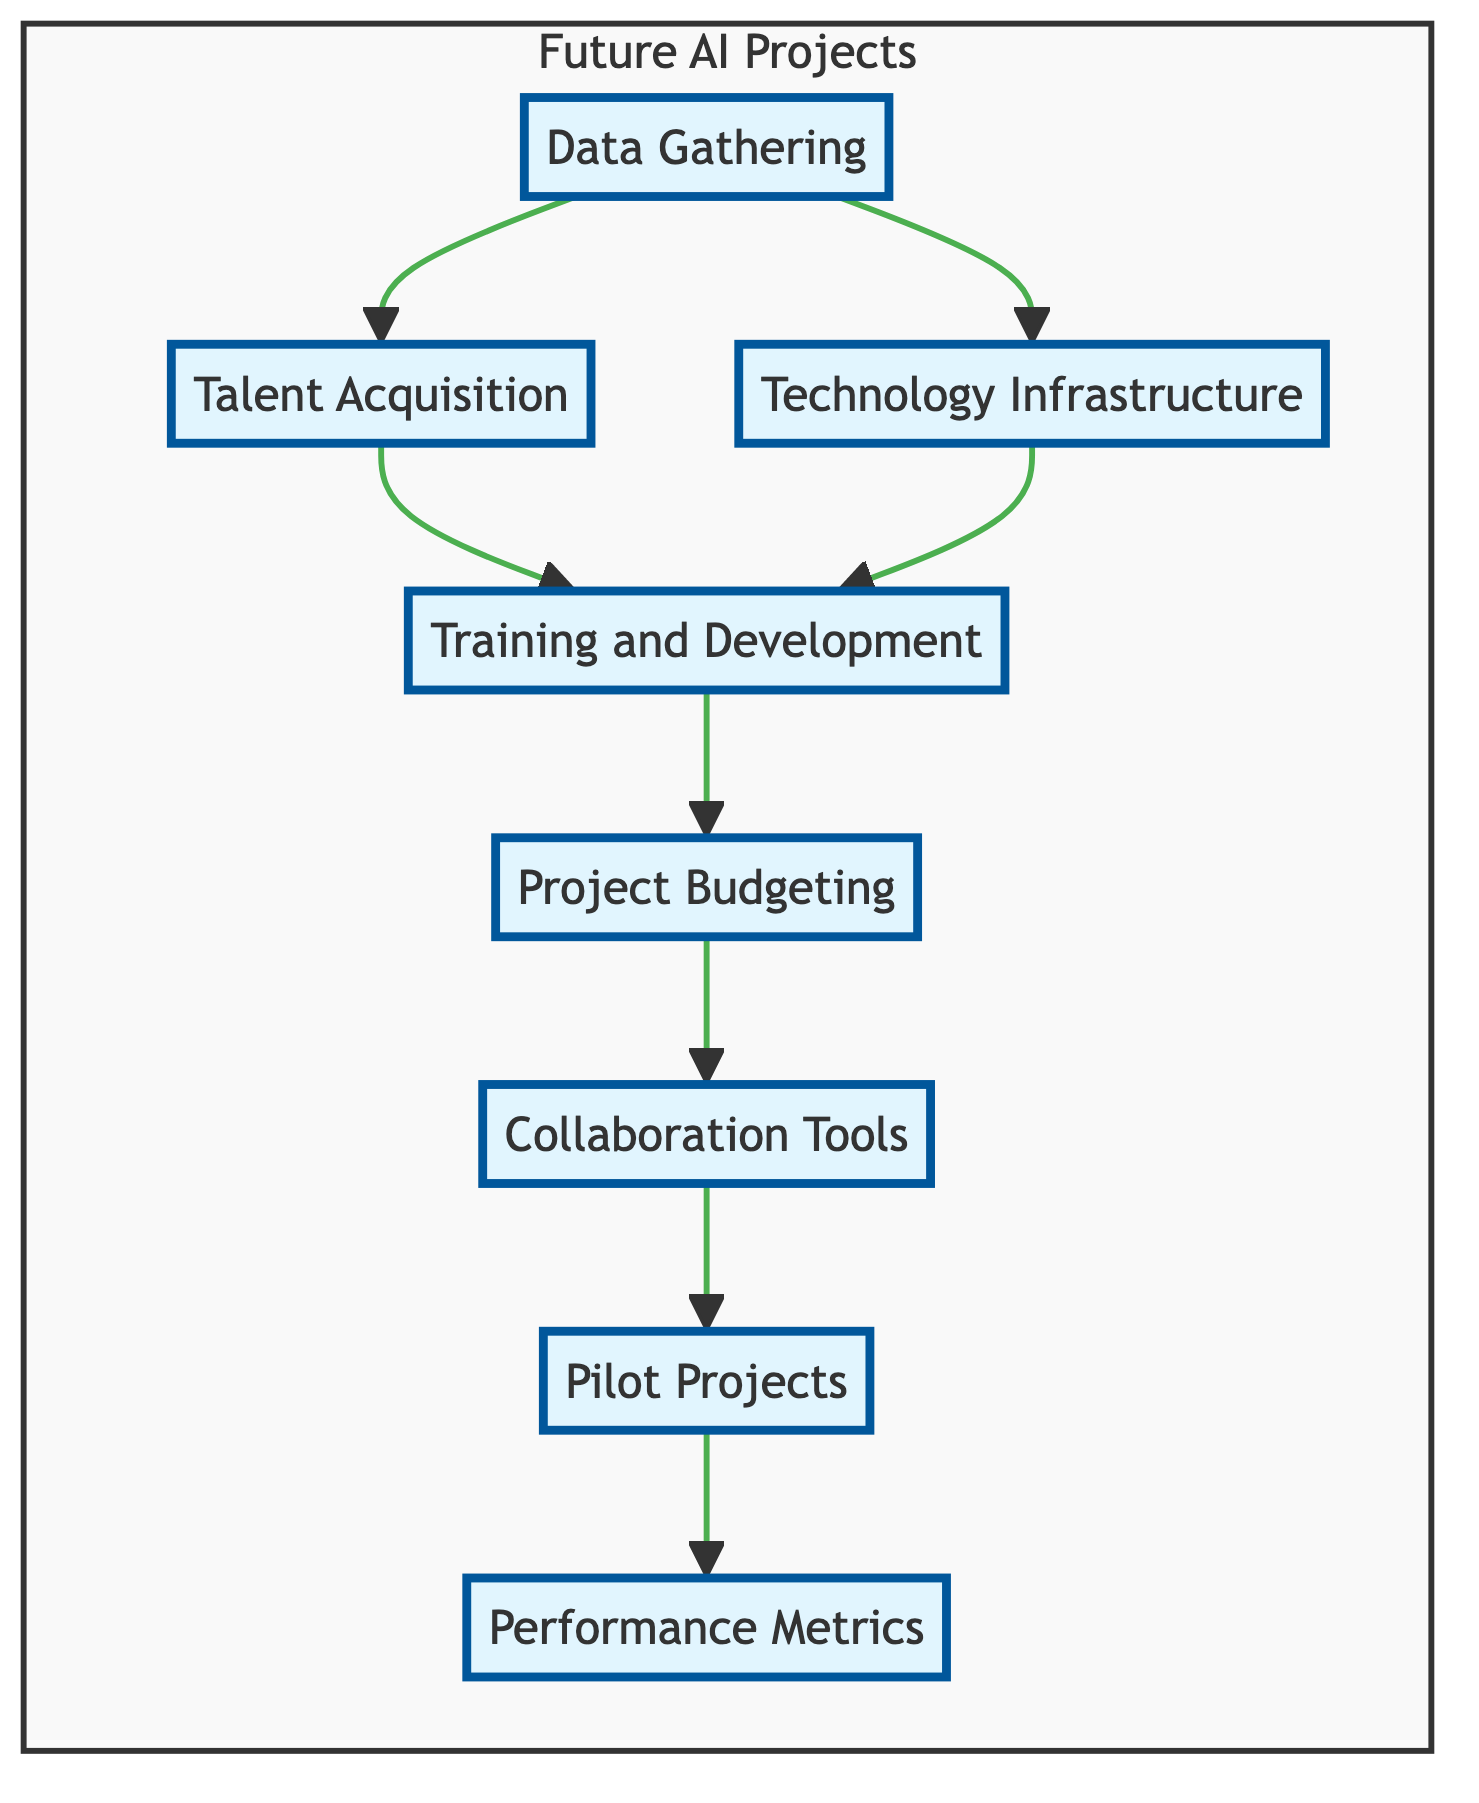What is the first step in the diagram? The diagram starts with "Data Gathering," which is the first node shown in the flow. There are no preceding nodes, so this is the initial action needed for the AI projects.
Answer: Data Gathering How many nodes are in the diagram? The diagram contains eight distinct nodes, each representing a critical step in the resource allocation process for AI projects.
Answer: Eight Which node comes after "Technology Infrastructure"? Following "Technology Infrastructure," the next node is "Training and Development," which is directly connected in the flow.
Answer: Training and Development What is the relationship between "Collaboration Tools" and "Project Budgeting"? "Collaboration Tools" is positioned after "Project Budgeting" in the flow. This indicates that financial resources need to be allocated first before implementing collaboration tools.
Answer: "Collaboration Tools" follows "Project Budgeting" What do "Pilot Projects" rely on according to the diagram? "Pilot Projects" depend on "Collaboration Tools" as indicated by the direct flow from "Collaboration Tools" to "Pilot Projects." Hence, they are reliant on those tools for execution.
Answer: Collaboration Tools What is the last step in the flow of the diagram? The last node reached in the diagram is "Performance Metrics," which summarizes the evaluation of the AI initiatives and is the final action taken.
Answer: Performance Metrics Which two nodes are connected after "Talent Acquisition"? Following "Talent Acquisition," the nodes "Training and Development" and "Technology Infrastructure" are both connected, as they both receive input from it, indicating multiple pathways from this node.
Answer: Training and Development, Technology Infrastructure What is necessary for analyzing the success of AI initiatives? The node "Performance Metrics" is specifically designed to establish key performance indicators necessary to measure the success of all AI initiatives implemented within the projects.
Answer: Performance Metrics 